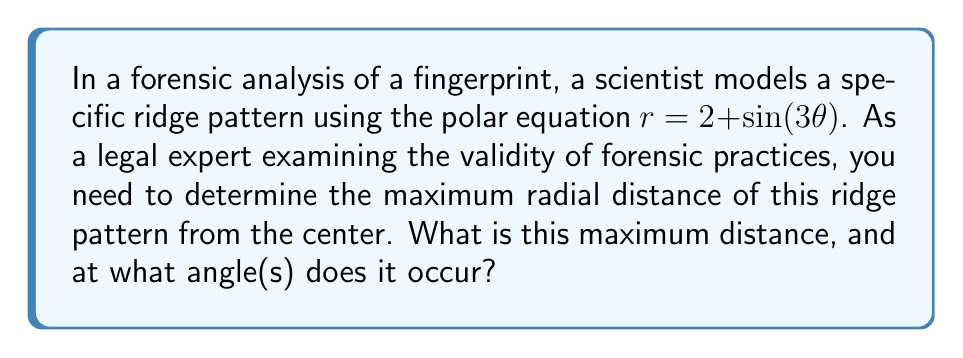Could you help me with this problem? To solve this problem, we need to follow these steps:

1) The given equation is $r = 2 + \sin(3\theta)$. To find the maximum value of $r$, we need to find the maximum value of $\sin(3\theta)$.

2) We know that the maximum value of sine is 1, which occurs when its argument is $\frac{\pi}{2}$ (or 90°) plus any multiple of $2\pi$.

3) So, we need to solve:
   $3\theta = \frac{\pi}{2} + 2\pi n$, where $n$ is any integer.

4) Solving for $\theta$:
   $\theta = \frac{\pi}{6} + \frac{2\pi n}{3}$

5) The first occurrence of the maximum (when $n=0$) is at $\theta = \frac{\pi}{6}$ or 30°.

6) At this angle, the maximum radial distance is:
   $r_{max} = 2 + \sin(3 \cdot \frac{\pi}{6}) = 2 + \sin(\frac{\pi}{2}) = 2 + 1 = 3$

7) This maximum repeats every $\frac{2\pi}{3}$ radians or 120°, due to the periodicity of the sine function and the factor of 3 in the argument.

Therefore, the maximum radial distance is 3 units, occurring at angles $\frac{\pi}{6} + \frac{2\pi n}{3}$ radians or $30° + 120°n$, where $n$ is any integer.

This analysis demonstrates the importance of understanding the mathematical models used in forensic science, which is crucial for evaluating the reliability and accuracy of fingerprint analysis techniques in legal proceedings.
Answer: The maximum radial distance is 3 units, occurring at angles $\theta = \frac{\pi}{6} + \frac{2\pi n}{3}$ radians or $30° + 120°n$, where $n$ is any integer. 